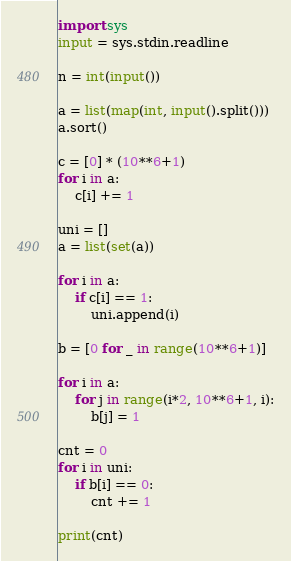Convert code to text. <code><loc_0><loc_0><loc_500><loc_500><_Python_>import sys
input = sys.stdin.readline

n = int(input())

a = list(map(int, input().split()))
a.sort()

c = [0] * (10**6+1)
for i in a:
    c[i] += 1

uni = []
a = list(set(a))

for i in a:
    if c[i] == 1:
        uni.append(i)

b = [0 for _ in range(10**6+1)]

for i in a:
    for j in range(i*2, 10**6+1, i):
        b[j] = 1

cnt = 0
for i in uni:
    if b[i] == 0:
        cnt += 1

print(cnt)</code> 